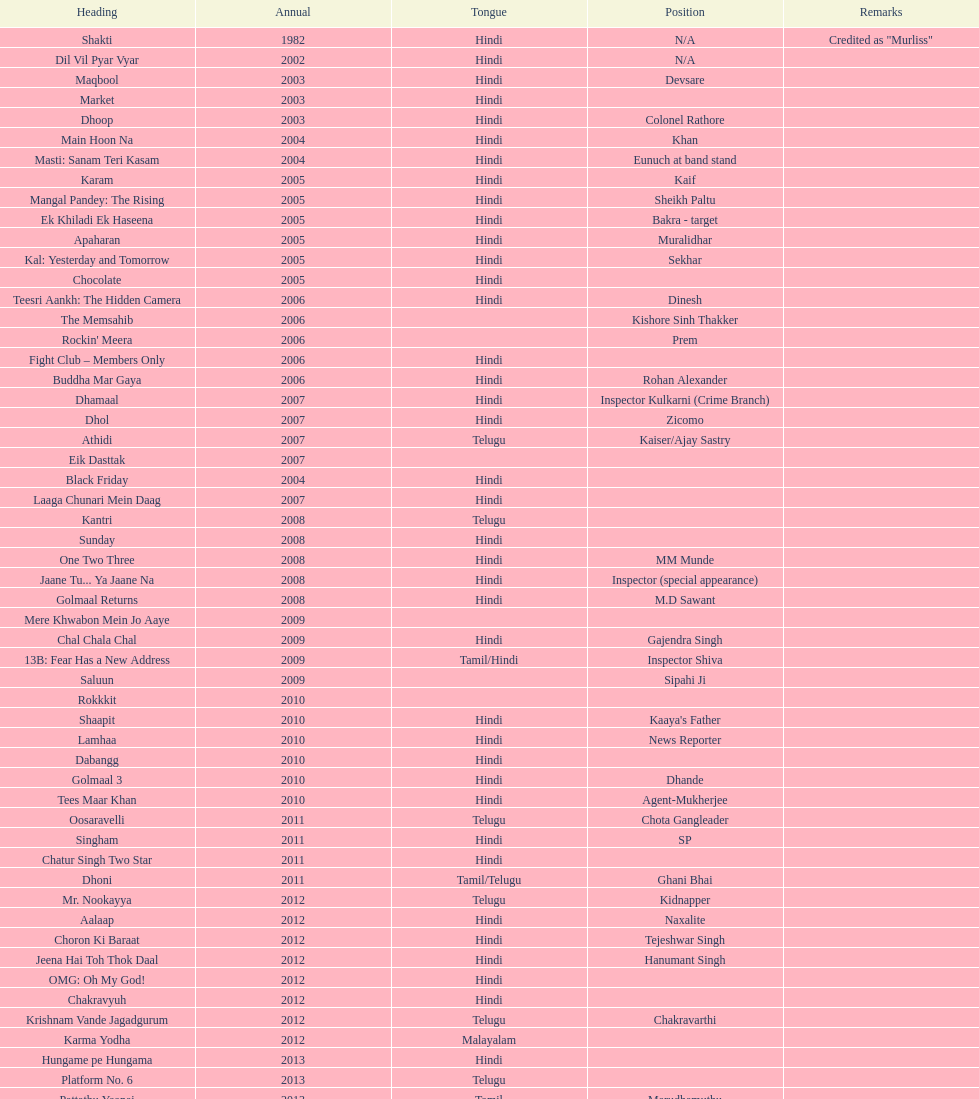What are the number of titles listed in 2005? 6. 